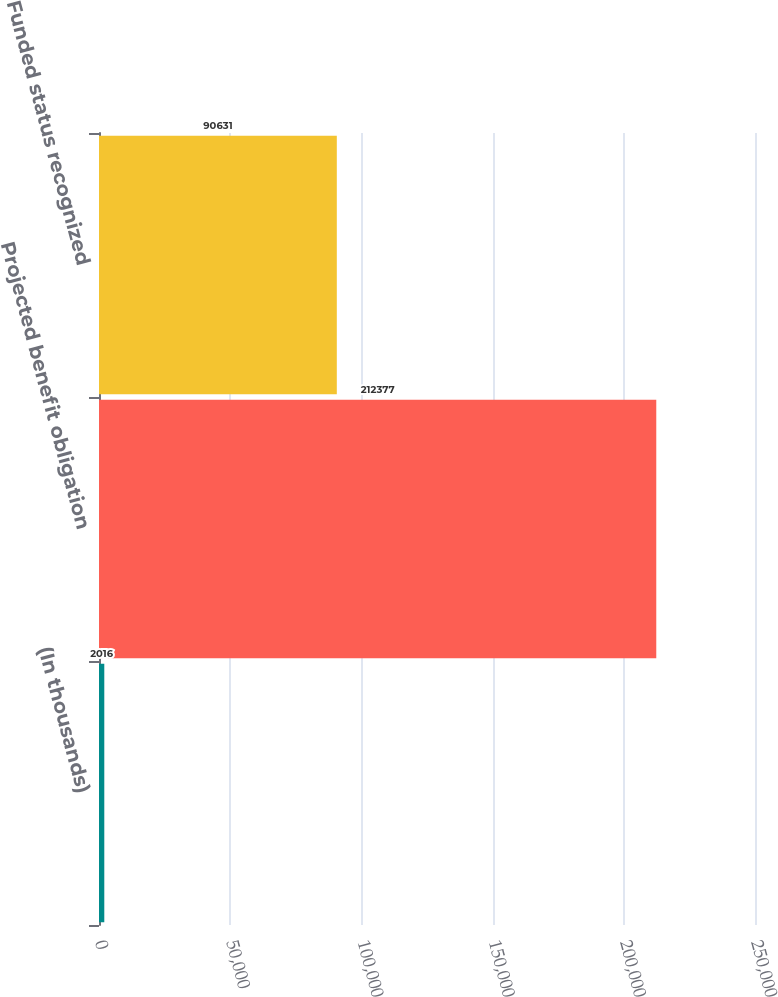Convert chart to OTSL. <chart><loc_0><loc_0><loc_500><loc_500><bar_chart><fcel>(In thousands)<fcel>Projected benefit obligation<fcel>Funded status recognized<nl><fcel>2016<fcel>212377<fcel>90631<nl></chart> 